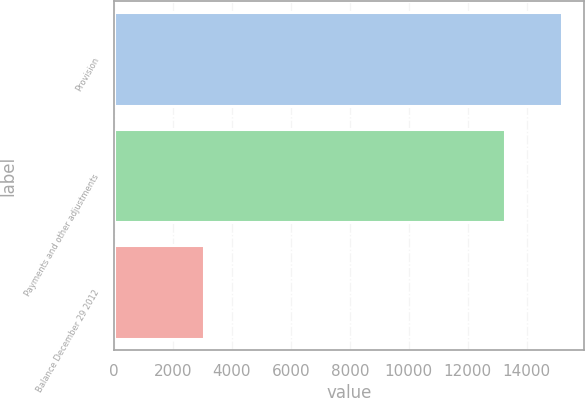Convert chart to OTSL. <chart><loc_0><loc_0><loc_500><loc_500><bar_chart><fcel>Provision<fcel>Payments and other adjustments<fcel>Balance December 29 2012<nl><fcel>15192<fcel>13255<fcel>3057<nl></chart> 